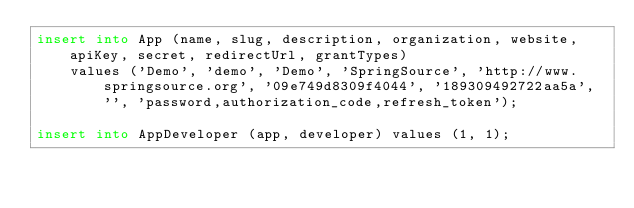<code> <loc_0><loc_0><loc_500><loc_500><_SQL_>insert into App (name, slug, description, organization, website, apiKey, secret, redirectUrl, grantTypes)
    values ('Demo', 'demo', 'Demo', 'SpringSource', 'http://www.springsource.org', '09e749d8309f4044', '189309492722aa5a', '', 'password,authorization_code,refresh_token');

insert into AppDeveloper (app, developer) values (1, 1);</code> 